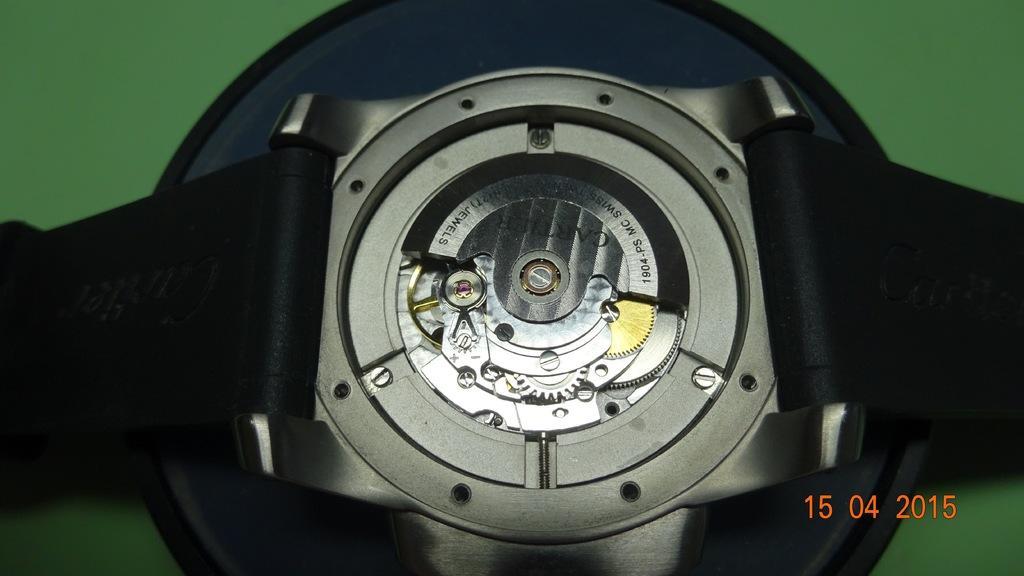Describe this image in one or two sentences. In this picture we can see belts and device. In the background of the image it is green. 